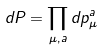Convert formula to latex. <formula><loc_0><loc_0><loc_500><loc_500>d P = \prod _ { \mu , a } d p _ { \mu } ^ { a }</formula> 